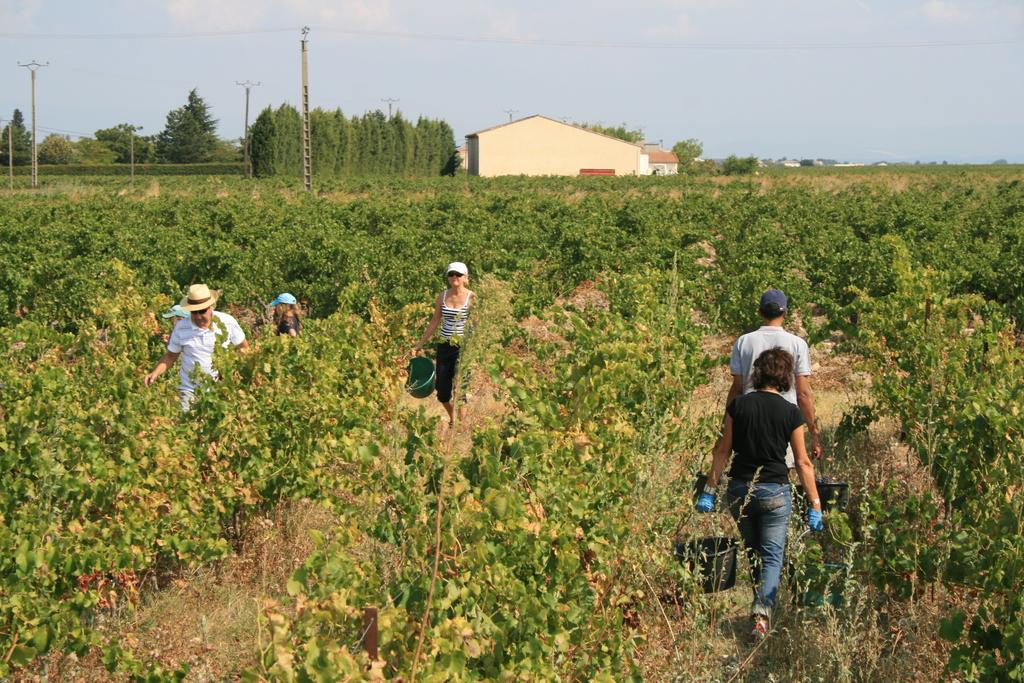How many people are present in the image? There are people in the image, but the exact number is not specified. What are the people holding in the image? The people are holding objects in the image. What is the setting in which the people are walking? The people are walking on a path in the image. What can be seen in the background of the image? In the background of the image, there are plants, trees, houses, electric poles with cables, and the sky. What type of fruit is hanging from the electric poles in the image? There are no fruit mentioned or visible in the image. The image features people walking on a path, with various elements visible in the background, including electric poles with cables. However, there is no mention or presence of fruit hanging from the electric poles in the image. 